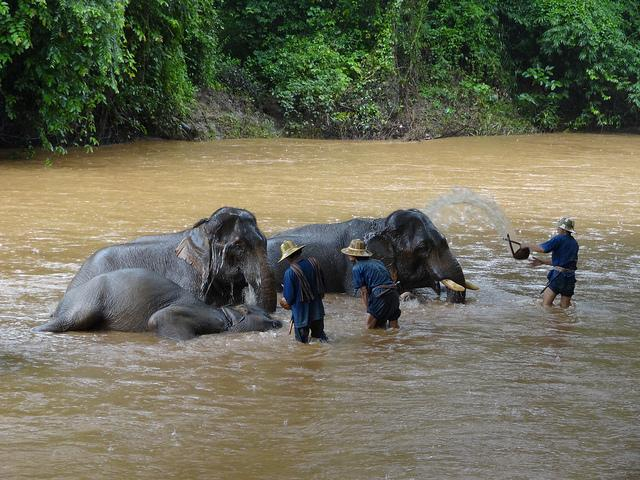Why is the water brown? Please explain your reasoning. dirt. The water has dirt. 